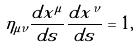<formula> <loc_0><loc_0><loc_500><loc_500>\eta _ { \mu \nu } \frac { d x ^ { \mu } } { d s } \frac { d x ^ { \nu } } { d s } = 1 ,</formula> 